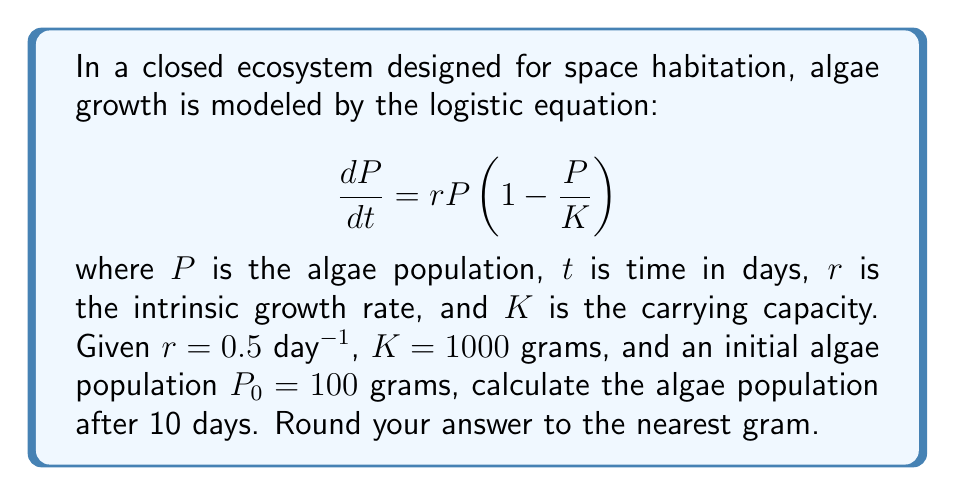What is the answer to this math problem? To solve this problem, we'll use the analytical solution of the logistic equation:

1) The solution to the logistic equation is:

   $$P(t) = \frac{KP_0e^{rt}}{K + P_0(e^{rt} - 1)}$$

2) We're given:
   $r = 0.5$ day$^{-1}$
   $K = 1000$ grams
   $P_0 = 100$ grams
   $t = 10$ days

3) Let's substitute these values into the equation:

   $$P(10) = \frac{1000 \cdot 100 \cdot e^{0.5 \cdot 10}}{1000 + 100(e^{0.5 \cdot 10} - 1)}$$

4) First, calculate $e^{0.5 \cdot 10}$:
   $e^5 \approx 148.4132$

5) Now, substitute this value:

   $$P(10) = \frac{100000 \cdot 148.4132}{1000 + 100(148.4132 - 1)}$$

6) Simplify:

   $$P(10) = \frac{14841320}{1000 + 14741.32} = \frac{14841320}{15741.32}$$

7) Calculate the final result:
   $P(10) \approx 943.46$ grams

8) Rounding to the nearest gram:
   $P(10) \approx 943$ grams
Answer: 943 grams 